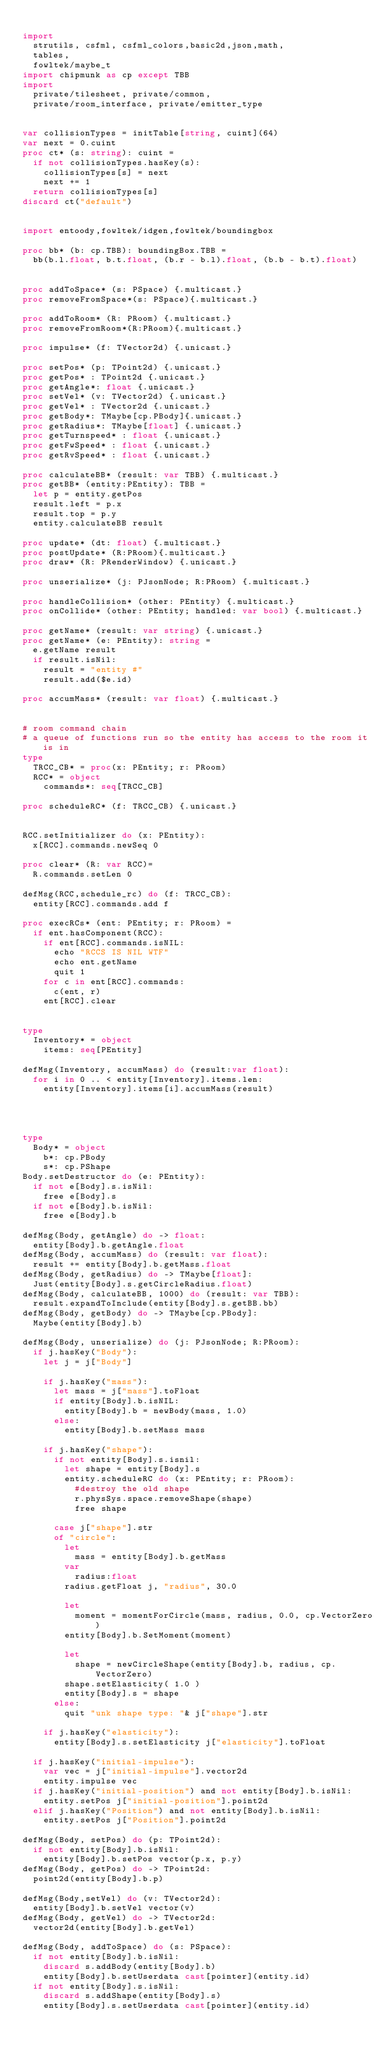Convert code to text. <code><loc_0><loc_0><loc_500><loc_500><_Nim_>
import 
  strutils, csfml, csfml_colors,basic2d,json,math,
  tables,
  fowltek/maybe_t
import chipmunk as cp except TBB
import
  private/tilesheet, private/common,
  private/room_interface, private/emitter_type


var collisionTypes = initTable[string, cuint](64)
var next = 0.cuint
proc ct* (s: string): cuint = 
  if not collisionTypes.hasKey(s):
    collisionTypes[s] = next
    next += 1
  return collisionTypes[s]
discard ct("default")


import entoody,fowltek/idgen,fowltek/boundingbox

proc bb* (b: cp.TBB): boundingBox.TBB =
  bb(b.l.float, b.t.float, (b.r - b.l).float, (b.b - b.t).float)


proc addToSpace* (s: PSpace) {.multicast.}
proc removeFromSpace*(s: PSpace){.multicast.}

proc addToRoom* (R: PRoom) {.multicast.}
proc removeFromRoom*(R:PRoom){.multicast.}

proc impulse* (f: TVector2d) {.unicast.}

proc setPos* (p: TPoint2d) {.unicast.}
proc getPos* : TPoint2d {.unicast.}
proc getAngle*: float {.unicast.}
proc setVel* (v: TVector2d) {.unicast.}
proc getVel* : TVector2d {.unicast.}
proc getBody*: TMaybe[cp.PBody]{.unicast.}
proc getRadius*: TMaybe[float] {.unicast.}
proc getTurnspeed* : float {.unicast.}
proc getFwSpeed* : float {.unicast.}
proc getRvSpeed* : float {.unicast.}

proc calculateBB* (result: var TBB) {.multicast.}
proc getBB* (entity:PEntity): TBB =
  let p = entity.getPos
  result.left = p.x
  result.top = p.y
  entity.calculateBB result

proc update* (dt: float) {.multicast.}
proc postUpdate* (R:PRoom){.multicast.}
proc draw* (R: PRenderWindow) {.unicast.}

proc unserialize* (j: PJsonNode; R:PRoom) {.multicast.}

proc handleCollision* (other: PEntity) {.multicast.}
proc onCollide* (other: PEntity; handled: var bool) {.multicast.}

proc getName* (result: var string) {.unicast.}
proc getName* (e: PEntity): string =
  e.getName result
  if result.isNil:
    result = "entity #"
    result.add($e.id)

proc accumMass* (result: var float) {.multicast.}


# room command chain
# a queue of functions run so the entity has access to the room it is in
type
  TRCC_CB* = proc(x: PEntity; r: PRoom)
  RCC* = object
    commands*: seq[TRCC_CB]

proc scheduleRC* (f: TRCC_CB) {.unicast.}


RCC.setInitializer do (x: PEntity):
  x[RCC].commands.newSeq 0
  
proc clear* (R: var RCC)= 
  R.commands.setLen 0

defMsg(RCC,schedule_rc) do (f: TRCC_CB):
  entity[RCC].commands.add f

proc execRCs* (ent: PEntity; r: PRoom) =
  if ent.hasComponent(RCC):
    if ent[RCC].commands.isNIL:
      echo "RCCS IS NIL WTF"
      echo ent.getName
      quit 1
    for c in ent[RCC].commands:
      c(ent, r)
    ent[RCC].clear


type
  Inventory* = object
    items: seq[PEntity]

defMsg(Inventory, accumMass) do (result:var float):
  for i in 0 .. < entity[Inventory].items.len:
    entity[Inventory].items[i].accumMass(result)




type
  Body* = object
    b*: cp.PBody
    s*: cp.PShape
Body.setDestructor do (e: PEntity):
  if not e[Body].s.isNil:
    free e[Body].s
  if not e[Body].b.isNil:
    free e[Body].b

defMsg(Body, getAngle) do -> float:
  entity[Body].b.getAngle.float
defMsg(Body, accumMass) do (result: var float):
  result += entity[Body].b.getMass.float
defMsg(Body, getRadius) do -> TMaybe[float]:
  Just(entity[Body].s.getCircleRadius.float)
defMsg(Body, calculateBB, 1000) do (result: var TBB):
  result.expandToInclude(entity[Body].s.getBB.bb)
defMsg(Body, getBody) do -> TMaybe[cp.PBody]:
  Maybe(entity[Body].b)

defMsg(Body, unserialize) do (j: PJsonNode; R:PRoom):
  if j.hasKey("Body"):
    let j = j["Body"]
    
    if j.hasKey("mass"):
      let mass = j["mass"].toFloat
      if entity[Body].b.isNIL:
        entity[Body].b = newBody(mass, 1.0)
      else:
        entity[Body].b.setMass mass

    if j.hasKey("shape"):
      if not entity[Body].s.isnil:
        let shape = entity[Body].s
        entity.scheduleRC do (x: PEntity; r: PRoom):
          #destroy the old shape
          r.physSys.space.removeShape(shape)
          free shape

      case j["shape"].str
      of "circle":
        let 
          mass = entity[Body].b.getMass
        var 
          radius:float
        radius.getFloat j, "radius", 30.0
        
        let 
          moment = momentForCircle(mass, radius, 0.0, cp.VectorZero)
        entity[Body].b.SetMoment(moment)
        
        let
          shape = newCircleShape(entity[Body].b, radius, cp.VectorZero)
        shape.setElasticity( 1.0 )
        entity[Body].s = shape
      else:
        quit "unk shape type: "& j["shape"].str
  
    if j.hasKey("elasticity"):
      entity[Body].s.setElasticity j["elasticity"].toFloat
  
  if j.hasKey("initial-impulse"):
    var vec = j["initial-impulse"].vector2d
    entity.impulse vec
  if j.hasKey("initial-position") and not entity[Body].b.isNil:
    entity.setPos j["initial-position"].point2d
  elif j.hasKey("Position") and not entity[Body].b.isNil:
    entity.setPos j["Position"].point2d

defMsg(Body, setPos) do (p: TPoint2d):
  if not entity[Body].b.isNil:
    entity[Body].b.setPos vector(p.x, p.y)
defMsg(Body, getPos) do -> TPoint2d:
  point2d(entity[Body].b.p)

defMsg(Body,setVel) do (v: TVector2d):
  entity[Body].b.setVel vector(v)
defMsg(Body, getVel) do -> TVector2d:
  vector2d(entity[Body].b.getVel)

defMsg(Body, addToSpace) do (s: PSpace):
  if not entity[Body].b.isNil:
    discard s.addBody(entity[Body].b)
    entity[Body].b.setUserdata cast[pointer](entity.id)
  if not entity[Body].s.isNil:
    discard s.addShape(entity[Body].s)
    entity[Body].s.setUserdata cast[pointer](entity.id)</code> 